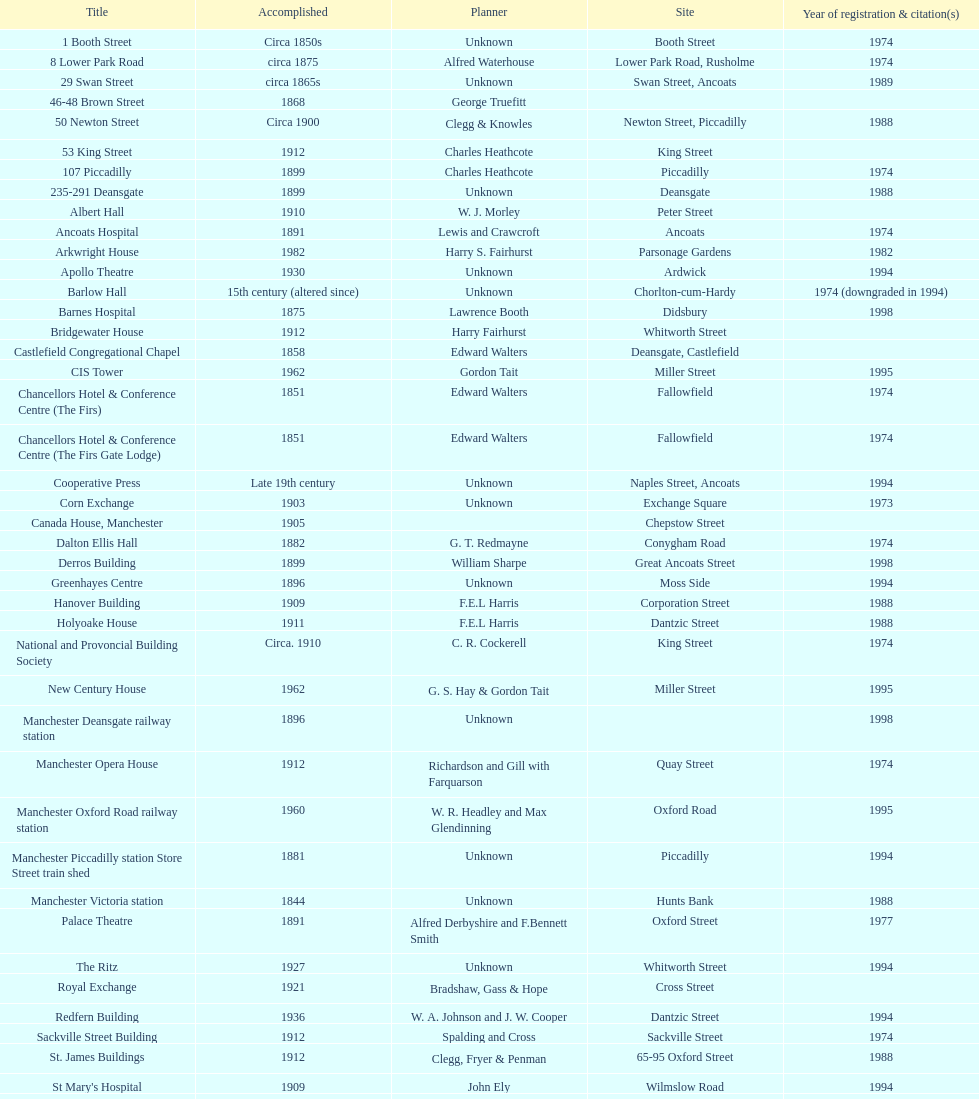Could you parse the entire table? {'header': ['Title', 'Accomplished', 'Planner', 'Site', 'Year of registration & citation(s)'], 'rows': [['1 Booth Street', 'Circa 1850s', 'Unknown', 'Booth Street', '1974'], ['8 Lower Park Road', 'circa 1875', 'Alfred Waterhouse', 'Lower Park Road, Rusholme', '1974'], ['29 Swan Street', 'circa 1865s', 'Unknown', 'Swan Street, Ancoats', '1989'], ['46-48 Brown Street', '1868', 'George Truefitt', '', ''], ['50 Newton Street', 'Circa 1900', 'Clegg & Knowles', 'Newton Street, Piccadilly', '1988'], ['53 King Street', '1912', 'Charles Heathcote', 'King Street', ''], ['107 Piccadilly', '1899', 'Charles Heathcote', 'Piccadilly', '1974'], ['235-291 Deansgate', '1899', 'Unknown', 'Deansgate', '1988'], ['Albert Hall', '1910', 'W. J. Morley', 'Peter Street', ''], ['Ancoats Hospital', '1891', 'Lewis and Crawcroft', 'Ancoats', '1974'], ['Arkwright House', '1982', 'Harry S. Fairhurst', 'Parsonage Gardens', '1982'], ['Apollo Theatre', '1930', 'Unknown', 'Ardwick', '1994'], ['Barlow Hall', '15th century (altered since)', 'Unknown', 'Chorlton-cum-Hardy', '1974 (downgraded in 1994)'], ['Barnes Hospital', '1875', 'Lawrence Booth', 'Didsbury', '1998'], ['Bridgewater House', '1912', 'Harry Fairhurst', 'Whitworth Street', ''], ['Castlefield Congregational Chapel', '1858', 'Edward Walters', 'Deansgate, Castlefield', ''], ['CIS Tower', '1962', 'Gordon Tait', 'Miller Street', '1995'], ['Chancellors Hotel & Conference Centre (The Firs)', '1851', 'Edward Walters', 'Fallowfield', '1974'], ['Chancellors Hotel & Conference Centre (The Firs Gate Lodge)', '1851', 'Edward Walters', 'Fallowfield', '1974'], ['Cooperative Press', 'Late 19th century', 'Unknown', 'Naples Street, Ancoats', '1994'], ['Corn Exchange', '1903', 'Unknown', 'Exchange Square', '1973'], ['Canada House, Manchester', '1905', '', 'Chepstow Street', ''], ['Dalton Ellis Hall', '1882', 'G. T. Redmayne', 'Conygham Road', '1974'], ['Derros Building', '1899', 'William Sharpe', 'Great Ancoats Street', '1998'], ['Greenhayes Centre', '1896', 'Unknown', 'Moss Side', '1994'], ['Hanover Building', '1909', 'F.E.L Harris', 'Corporation Street', '1988'], ['Holyoake House', '1911', 'F.E.L Harris', 'Dantzic Street', '1988'], ['National and Provoncial Building Society', 'Circa. 1910', 'C. R. Cockerell', 'King Street', '1974'], ['New Century House', '1962', 'G. S. Hay & Gordon Tait', 'Miller Street', '1995'], ['Manchester Deansgate railway station', '1896', 'Unknown', '', '1998'], ['Manchester Opera House', '1912', 'Richardson and Gill with Farquarson', 'Quay Street', '1974'], ['Manchester Oxford Road railway station', '1960', 'W. R. Headley and Max Glendinning', 'Oxford Road', '1995'], ['Manchester Piccadilly station Store Street train shed', '1881', 'Unknown', 'Piccadilly', '1994'], ['Manchester Victoria station', '1844', 'Unknown', 'Hunts Bank', '1988'], ['Palace Theatre', '1891', 'Alfred Derbyshire and F.Bennett Smith', 'Oxford Street', '1977'], ['The Ritz', '1927', 'Unknown', 'Whitworth Street', '1994'], ['Royal Exchange', '1921', 'Bradshaw, Gass & Hope', 'Cross Street', ''], ['Redfern Building', '1936', 'W. A. Johnson and J. W. Cooper', 'Dantzic Street', '1994'], ['Sackville Street Building', '1912', 'Spalding and Cross', 'Sackville Street', '1974'], ['St. James Buildings', '1912', 'Clegg, Fryer & Penman', '65-95 Oxford Street', '1988'], ["St Mary's Hospital", '1909', 'John Ely', 'Wilmslow Road', '1994'], ['Samuel Alexander Building', '1919', 'Percy Scott Worthington', 'Oxford Road', '2010'], ['Ship Canal House', '1927', 'Harry S. Fairhurst', 'King Street', '1982'], ['Smithfield Market Hall', '1857', 'Unknown', 'Swan Street, Ancoats', '1973'], ['Strangeways Gaol Gatehouse', '1868', 'Alfred Waterhouse', 'Sherborne Street', '1974'], ['Strangeways Prison ventilation and watch tower', '1868', 'Alfred Waterhouse', 'Sherborne Street', '1974'], ['Theatre Royal', '1845', 'Irwin and Chester', 'Peter Street', '1974'], ['Toast Rack', '1960', 'L. C. Howitt', 'Fallowfield', '1999'], ['The Old Wellington Inn', 'Mid-16th century', 'Unknown', 'Shambles Square', '1952'], ['Whitworth Park Mansions', 'Circa 1840s', 'Unknown', 'Whitworth Park', '1974']]} Which two structures were catalogued prior to 1974? The Old Wellington Inn, Smithfield Market Hall. 